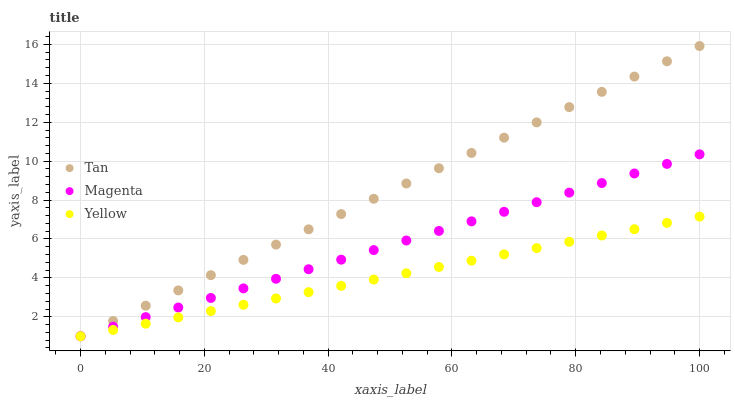Does Yellow have the minimum area under the curve?
Answer yes or no. Yes. Does Tan have the maximum area under the curve?
Answer yes or no. Yes. Does Magenta have the minimum area under the curve?
Answer yes or no. No. Does Magenta have the maximum area under the curve?
Answer yes or no. No. Is Yellow the smoothest?
Answer yes or no. Yes. Is Tan the roughest?
Answer yes or no. Yes. Is Magenta the smoothest?
Answer yes or no. No. Is Magenta the roughest?
Answer yes or no. No. Does Tan have the lowest value?
Answer yes or no. Yes. Does Tan have the highest value?
Answer yes or no. Yes. Does Magenta have the highest value?
Answer yes or no. No. Does Yellow intersect Magenta?
Answer yes or no. Yes. Is Yellow less than Magenta?
Answer yes or no. No. Is Yellow greater than Magenta?
Answer yes or no. No. 